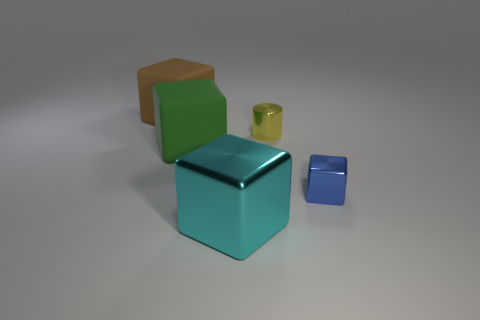Add 5 brown objects. How many objects exist? 10 Subtract all purple blocks. Subtract all cyan balls. How many blocks are left? 4 Subtract all cubes. How many objects are left? 1 Subtract 0 cyan balls. How many objects are left? 5 Subtract all brown blocks. Subtract all brown cubes. How many objects are left? 3 Add 2 metal blocks. How many metal blocks are left? 4 Add 3 large brown spheres. How many large brown spheres exist? 3 